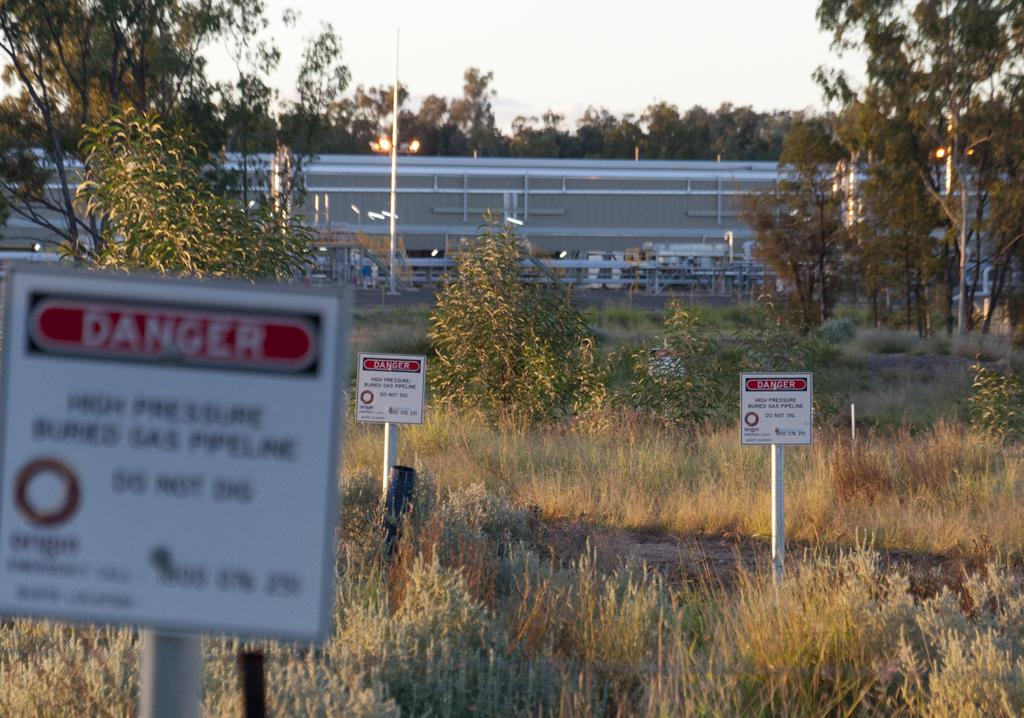What type of signage is present in the image? There are white color caution boards in the image. How are the caution boards positioned? The caution boards are fixed to poles. What can be seen on the ground in the image? There is dried grass on the ground in the image. What is visible in the background of the image? There are trees and the sky visible in the background of the image. How many birds are sitting on the caution boards in the image? There are no birds present on the caution boards in the image. What type of chalk is used to draw on the caution boards in the image? There is no chalk visible on the caution boards in the image. 